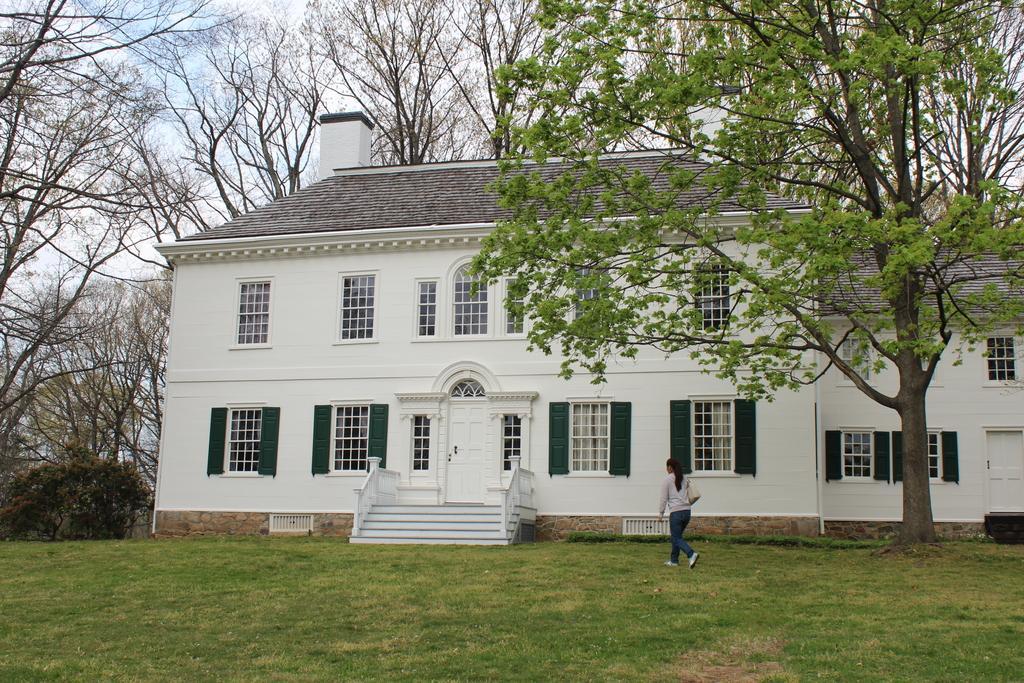Can you describe this image briefly? This is the picture of a building. In this image there is a building and there is a woman walking on the grass. At the back there are trees. At the top there is sky and there are clouds. At the bottom there is grass. 